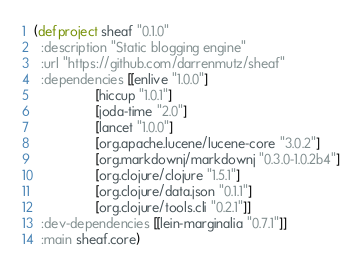Convert code to text. <code><loc_0><loc_0><loc_500><loc_500><_Clojure_>(defproject sheaf "0.1.0"
  :description "Static blogging engine"
  :url "https://github.com/darrenmutz/sheaf"
  :dependencies [[enlive "1.0.0"]
                 [hiccup "1.0.1"]
                 [joda-time "2.0"]
                 [lancet "1.0.0"]
                 [org.apache.lucene/lucene-core "3.0.2"]
                 [org.markdownj/markdownj "0.3.0-1.0.2b4"]
                 [org.clojure/clojure "1.5.1"]
                 [org.clojure/data.json "0.1.1"]
                 [org.clojure/tools.cli "0.2.1"]]
  :dev-dependencies [[lein-marginalia "0.7.1"]]
  :main sheaf.core)
</code> 